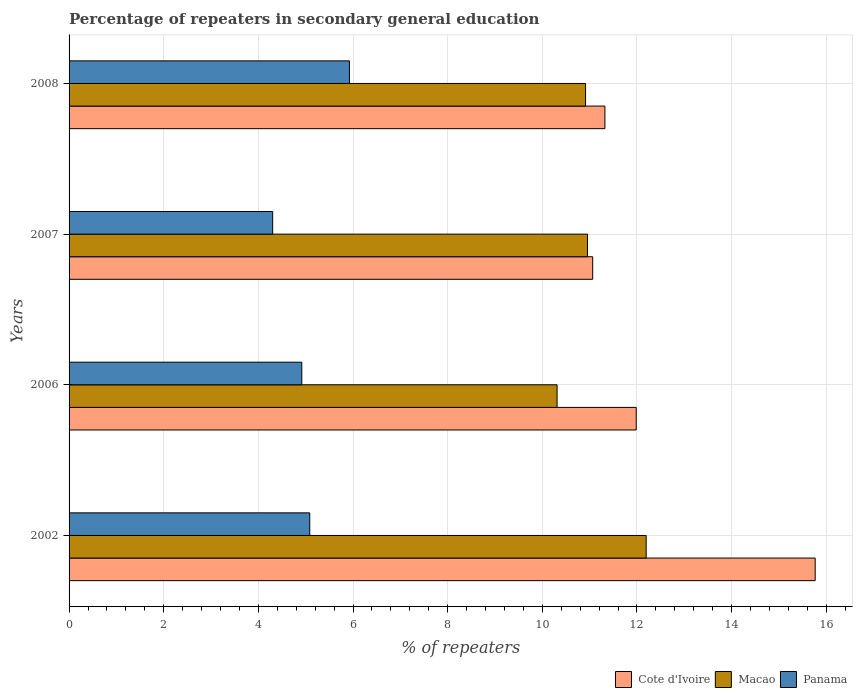How many groups of bars are there?
Offer a terse response. 4. Are the number of bars per tick equal to the number of legend labels?
Provide a short and direct response. Yes. Are the number of bars on each tick of the Y-axis equal?
Provide a succinct answer. Yes. How many bars are there on the 3rd tick from the top?
Your response must be concise. 3. How many bars are there on the 3rd tick from the bottom?
Offer a terse response. 3. What is the label of the 4th group of bars from the top?
Give a very brief answer. 2002. What is the percentage of repeaters in secondary general education in Panama in 2008?
Keep it short and to the point. 5.92. Across all years, what is the maximum percentage of repeaters in secondary general education in Macao?
Offer a very short reply. 12.19. Across all years, what is the minimum percentage of repeaters in secondary general education in Macao?
Ensure brevity in your answer.  10.31. What is the total percentage of repeaters in secondary general education in Macao in the graph?
Make the answer very short. 44.37. What is the difference between the percentage of repeaters in secondary general education in Cote d'Ivoire in 2007 and that in 2008?
Your answer should be very brief. -0.26. What is the difference between the percentage of repeaters in secondary general education in Macao in 2007 and the percentage of repeaters in secondary general education in Cote d'Ivoire in 2002?
Provide a succinct answer. -4.81. What is the average percentage of repeaters in secondary general education in Macao per year?
Give a very brief answer. 11.09. In the year 2007, what is the difference between the percentage of repeaters in secondary general education in Cote d'Ivoire and percentage of repeaters in secondary general education in Macao?
Your answer should be very brief. 0.11. In how many years, is the percentage of repeaters in secondary general education in Cote d'Ivoire greater than 10 %?
Keep it short and to the point. 4. What is the ratio of the percentage of repeaters in secondary general education in Cote d'Ivoire in 2002 to that in 2008?
Offer a terse response. 1.39. What is the difference between the highest and the second highest percentage of repeaters in secondary general education in Panama?
Offer a very short reply. 0.84. What is the difference between the highest and the lowest percentage of repeaters in secondary general education in Cote d'Ivoire?
Your response must be concise. 4.7. In how many years, is the percentage of repeaters in secondary general education in Cote d'Ivoire greater than the average percentage of repeaters in secondary general education in Cote d'Ivoire taken over all years?
Provide a succinct answer. 1. What does the 3rd bar from the top in 2006 represents?
Provide a short and direct response. Cote d'Ivoire. What does the 3rd bar from the bottom in 2002 represents?
Offer a terse response. Panama. How many bars are there?
Your answer should be compact. 12. Are all the bars in the graph horizontal?
Your answer should be very brief. Yes. What is the difference between two consecutive major ticks on the X-axis?
Ensure brevity in your answer.  2. Where does the legend appear in the graph?
Your answer should be compact. Bottom right. How are the legend labels stacked?
Keep it short and to the point. Horizontal. What is the title of the graph?
Your response must be concise. Percentage of repeaters in secondary general education. Does "Greenland" appear as one of the legend labels in the graph?
Offer a terse response. No. What is the label or title of the X-axis?
Make the answer very short. % of repeaters. What is the % of repeaters in Cote d'Ivoire in 2002?
Ensure brevity in your answer.  15.77. What is the % of repeaters in Macao in 2002?
Make the answer very short. 12.19. What is the % of repeaters in Panama in 2002?
Your response must be concise. 5.09. What is the % of repeaters in Cote d'Ivoire in 2006?
Give a very brief answer. 11.98. What is the % of repeaters in Macao in 2006?
Offer a very short reply. 10.31. What is the % of repeaters in Panama in 2006?
Your answer should be very brief. 4.92. What is the % of repeaters in Cote d'Ivoire in 2007?
Provide a succinct answer. 11.06. What is the % of repeaters in Macao in 2007?
Provide a short and direct response. 10.95. What is the % of repeaters in Panama in 2007?
Make the answer very short. 4.3. What is the % of repeaters in Cote d'Ivoire in 2008?
Offer a terse response. 11.32. What is the % of repeaters of Macao in 2008?
Offer a very short reply. 10.91. What is the % of repeaters of Panama in 2008?
Give a very brief answer. 5.92. Across all years, what is the maximum % of repeaters in Cote d'Ivoire?
Give a very brief answer. 15.77. Across all years, what is the maximum % of repeaters in Macao?
Give a very brief answer. 12.19. Across all years, what is the maximum % of repeaters in Panama?
Your answer should be compact. 5.92. Across all years, what is the minimum % of repeaters in Cote d'Ivoire?
Make the answer very short. 11.06. Across all years, what is the minimum % of repeaters in Macao?
Your response must be concise. 10.31. Across all years, what is the minimum % of repeaters in Panama?
Make the answer very short. 4.3. What is the total % of repeaters in Cote d'Ivoire in the graph?
Offer a very short reply. 50.14. What is the total % of repeaters in Macao in the graph?
Provide a succinct answer. 44.37. What is the total % of repeaters in Panama in the graph?
Offer a terse response. 20.23. What is the difference between the % of repeaters of Cote d'Ivoire in 2002 and that in 2006?
Keep it short and to the point. 3.78. What is the difference between the % of repeaters of Macao in 2002 and that in 2006?
Provide a succinct answer. 1.88. What is the difference between the % of repeaters of Panama in 2002 and that in 2006?
Make the answer very short. 0.17. What is the difference between the % of repeaters in Cote d'Ivoire in 2002 and that in 2007?
Provide a short and direct response. 4.7. What is the difference between the % of repeaters in Macao in 2002 and that in 2007?
Ensure brevity in your answer.  1.24. What is the difference between the % of repeaters in Panama in 2002 and that in 2007?
Your answer should be compact. 0.78. What is the difference between the % of repeaters in Cote d'Ivoire in 2002 and that in 2008?
Offer a very short reply. 4.44. What is the difference between the % of repeaters in Macao in 2002 and that in 2008?
Give a very brief answer. 1.28. What is the difference between the % of repeaters in Panama in 2002 and that in 2008?
Offer a terse response. -0.84. What is the difference between the % of repeaters of Cote d'Ivoire in 2006 and that in 2007?
Ensure brevity in your answer.  0.92. What is the difference between the % of repeaters of Macao in 2006 and that in 2007?
Keep it short and to the point. -0.64. What is the difference between the % of repeaters of Panama in 2006 and that in 2007?
Provide a succinct answer. 0.62. What is the difference between the % of repeaters in Cote d'Ivoire in 2006 and that in 2008?
Ensure brevity in your answer.  0.66. What is the difference between the % of repeaters in Macao in 2006 and that in 2008?
Provide a short and direct response. -0.6. What is the difference between the % of repeaters of Panama in 2006 and that in 2008?
Your response must be concise. -1.01. What is the difference between the % of repeaters in Cote d'Ivoire in 2007 and that in 2008?
Provide a short and direct response. -0.26. What is the difference between the % of repeaters of Macao in 2007 and that in 2008?
Provide a short and direct response. 0.04. What is the difference between the % of repeaters in Panama in 2007 and that in 2008?
Offer a very short reply. -1.62. What is the difference between the % of repeaters of Cote d'Ivoire in 2002 and the % of repeaters of Macao in 2006?
Keep it short and to the point. 5.45. What is the difference between the % of repeaters in Cote d'Ivoire in 2002 and the % of repeaters in Panama in 2006?
Keep it short and to the point. 10.85. What is the difference between the % of repeaters of Macao in 2002 and the % of repeaters of Panama in 2006?
Your answer should be very brief. 7.28. What is the difference between the % of repeaters in Cote d'Ivoire in 2002 and the % of repeaters in Macao in 2007?
Make the answer very short. 4.81. What is the difference between the % of repeaters of Cote d'Ivoire in 2002 and the % of repeaters of Panama in 2007?
Your answer should be compact. 11.46. What is the difference between the % of repeaters of Macao in 2002 and the % of repeaters of Panama in 2007?
Provide a succinct answer. 7.89. What is the difference between the % of repeaters of Cote d'Ivoire in 2002 and the % of repeaters of Macao in 2008?
Provide a succinct answer. 4.85. What is the difference between the % of repeaters of Cote d'Ivoire in 2002 and the % of repeaters of Panama in 2008?
Make the answer very short. 9.84. What is the difference between the % of repeaters in Macao in 2002 and the % of repeaters in Panama in 2008?
Your response must be concise. 6.27. What is the difference between the % of repeaters of Cote d'Ivoire in 2006 and the % of repeaters of Macao in 2007?
Give a very brief answer. 1.03. What is the difference between the % of repeaters in Cote d'Ivoire in 2006 and the % of repeaters in Panama in 2007?
Provide a short and direct response. 7.68. What is the difference between the % of repeaters in Macao in 2006 and the % of repeaters in Panama in 2007?
Make the answer very short. 6.01. What is the difference between the % of repeaters in Cote d'Ivoire in 2006 and the % of repeaters in Macao in 2008?
Your answer should be very brief. 1.07. What is the difference between the % of repeaters in Cote d'Ivoire in 2006 and the % of repeaters in Panama in 2008?
Offer a terse response. 6.06. What is the difference between the % of repeaters of Macao in 2006 and the % of repeaters of Panama in 2008?
Your answer should be compact. 4.39. What is the difference between the % of repeaters of Cote d'Ivoire in 2007 and the % of repeaters of Macao in 2008?
Ensure brevity in your answer.  0.15. What is the difference between the % of repeaters in Cote d'Ivoire in 2007 and the % of repeaters in Panama in 2008?
Your answer should be very brief. 5.14. What is the difference between the % of repeaters of Macao in 2007 and the % of repeaters of Panama in 2008?
Keep it short and to the point. 5.03. What is the average % of repeaters of Cote d'Ivoire per year?
Ensure brevity in your answer.  12.53. What is the average % of repeaters in Macao per year?
Offer a terse response. 11.09. What is the average % of repeaters in Panama per year?
Keep it short and to the point. 5.06. In the year 2002, what is the difference between the % of repeaters of Cote d'Ivoire and % of repeaters of Macao?
Your response must be concise. 3.57. In the year 2002, what is the difference between the % of repeaters of Cote d'Ivoire and % of repeaters of Panama?
Ensure brevity in your answer.  10.68. In the year 2002, what is the difference between the % of repeaters in Macao and % of repeaters in Panama?
Keep it short and to the point. 7.11. In the year 2006, what is the difference between the % of repeaters of Cote d'Ivoire and % of repeaters of Macao?
Keep it short and to the point. 1.67. In the year 2006, what is the difference between the % of repeaters of Cote d'Ivoire and % of repeaters of Panama?
Your answer should be very brief. 7.07. In the year 2006, what is the difference between the % of repeaters in Macao and % of repeaters in Panama?
Provide a succinct answer. 5.39. In the year 2007, what is the difference between the % of repeaters in Cote d'Ivoire and % of repeaters in Macao?
Your answer should be very brief. 0.11. In the year 2007, what is the difference between the % of repeaters of Cote d'Ivoire and % of repeaters of Panama?
Your answer should be very brief. 6.76. In the year 2007, what is the difference between the % of repeaters in Macao and % of repeaters in Panama?
Offer a terse response. 6.65. In the year 2008, what is the difference between the % of repeaters in Cote d'Ivoire and % of repeaters in Macao?
Ensure brevity in your answer.  0.41. In the year 2008, what is the difference between the % of repeaters of Cote d'Ivoire and % of repeaters of Panama?
Provide a short and direct response. 5.4. In the year 2008, what is the difference between the % of repeaters in Macao and % of repeaters in Panama?
Your answer should be compact. 4.99. What is the ratio of the % of repeaters in Cote d'Ivoire in 2002 to that in 2006?
Provide a succinct answer. 1.32. What is the ratio of the % of repeaters in Macao in 2002 to that in 2006?
Your answer should be very brief. 1.18. What is the ratio of the % of repeaters in Panama in 2002 to that in 2006?
Keep it short and to the point. 1.03. What is the ratio of the % of repeaters in Cote d'Ivoire in 2002 to that in 2007?
Provide a short and direct response. 1.42. What is the ratio of the % of repeaters of Macao in 2002 to that in 2007?
Make the answer very short. 1.11. What is the ratio of the % of repeaters of Panama in 2002 to that in 2007?
Keep it short and to the point. 1.18. What is the ratio of the % of repeaters of Cote d'Ivoire in 2002 to that in 2008?
Offer a very short reply. 1.39. What is the ratio of the % of repeaters in Macao in 2002 to that in 2008?
Ensure brevity in your answer.  1.12. What is the ratio of the % of repeaters in Panama in 2002 to that in 2008?
Provide a short and direct response. 0.86. What is the ratio of the % of repeaters of Cote d'Ivoire in 2006 to that in 2007?
Your response must be concise. 1.08. What is the ratio of the % of repeaters of Macao in 2006 to that in 2007?
Ensure brevity in your answer.  0.94. What is the ratio of the % of repeaters of Panama in 2006 to that in 2007?
Provide a succinct answer. 1.14. What is the ratio of the % of repeaters in Cote d'Ivoire in 2006 to that in 2008?
Keep it short and to the point. 1.06. What is the ratio of the % of repeaters in Macao in 2006 to that in 2008?
Ensure brevity in your answer.  0.94. What is the ratio of the % of repeaters in Panama in 2006 to that in 2008?
Provide a succinct answer. 0.83. What is the ratio of the % of repeaters in Cote d'Ivoire in 2007 to that in 2008?
Your answer should be compact. 0.98. What is the ratio of the % of repeaters of Panama in 2007 to that in 2008?
Ensure brevity in your answer.  0.73. What is the difference between the highest and the second highest % of repeaters of Cote d'Ivoire?
Provide a succinct answer. 3.78. What is the difference between the highest and the second highest % of repeaters in Macao?
Provide a short and direct response. 1.24. What is the difference between the highest and the second highest % of repeaters of Panama?
Ensure brevity in your answer.  0.84. What is the difference between the highest and the lowest % of repeaters of Cote d'Ivoire?
Your answer should be compact. 4.7. What is the difference between the highest and the lowest % of repeaters of Macao?
Your answer should be very brief. 1.88. What is the difference between the highest and the lowest % of repeaters of Panama?
Keep it short and to the point. 1.62. 